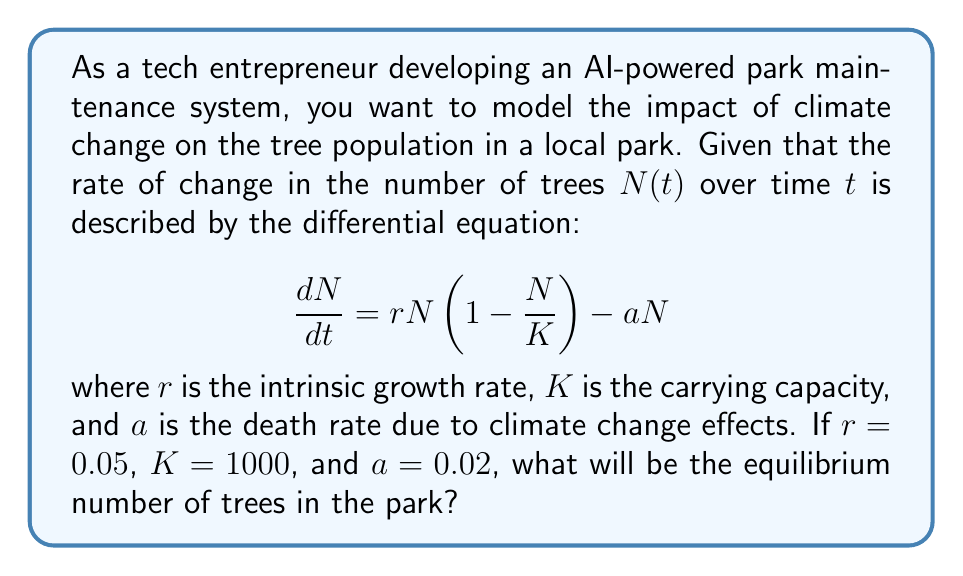Give your solution to this math problem. To solve this problem, we need to find the equilibrium point of the given differential equation. At equilibrium, the rate of change is zero, so we set $\frac{dN}{dt} = 0$:

$$0 = rN(1 - \frac{N}{K}) - aN$$

Substituting the given values:

$$0 = 0.05N(1 - \frac{N}{1000}) - 0.02N$$

Expanding the equation:

$$0 = 0.05N - \frac{0.05N^2}{1000} - 0.02N$$

Simplifying:

$$0 = 0.03N - \frac{0.05N^2}{1000}$$

Multiplying both sides by 1000:

$$0 = 30N - 0.05N^2$$

Factoring out N:

$$0 = N(30 - 0.05N)$$

This equation has two solutions: $N = 0$ or $30 - 0.05N = 0$. The non-zero solution is of interest here, so we solve:

$$30 - 0.05N = 0$$
$$30 = 0.05N$$
$$N = \frac{30}{0.05} = 600$$

Therefore, the equilibrium number of trees in the park will be 600.
Answer: The equilibrium number of trees in the park will be 600. 